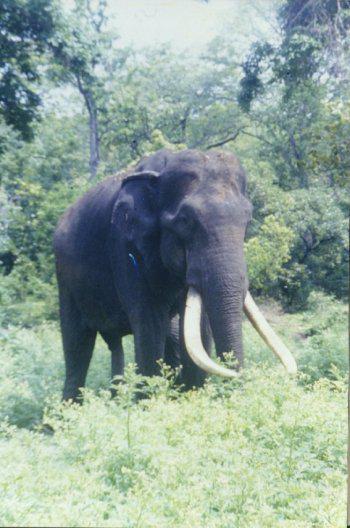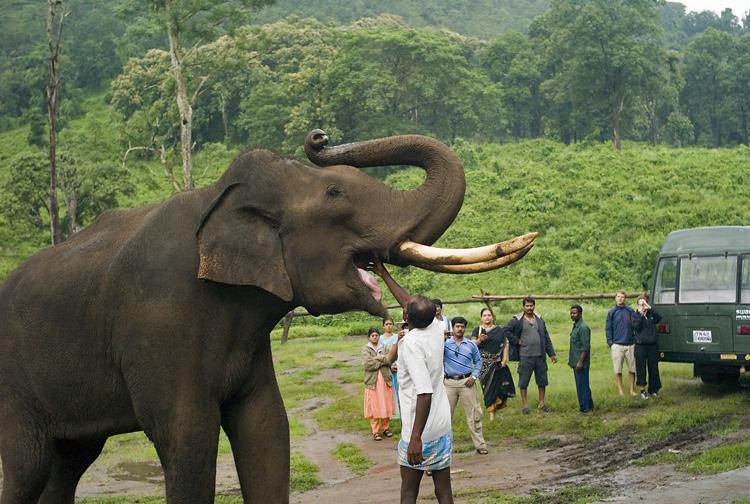The first image is the image on the left, the second image is the image on the right. Given the left and right images, does the statement "At baby elephant is near at least 1 other grown elephant." hold true? Answer yes or no. No. 